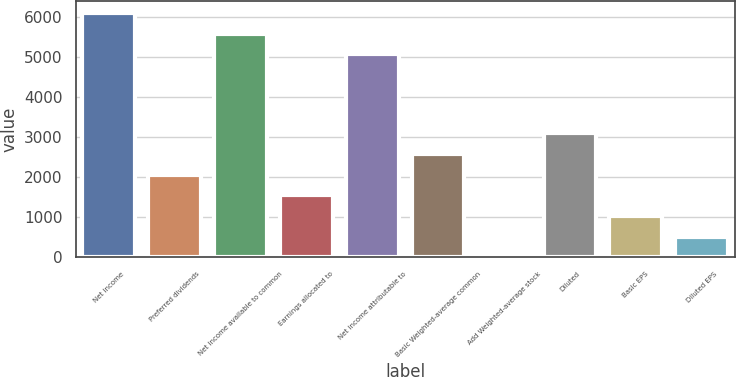Convert chart to OTSL. <chart><loc_0><loc_0><loc_500><loc_500><bar_chart><fcel>Net income<fcel>Preferred dividends<fcel>Net income available to common<fcel>Earnings allocated to<fcel>Net income attributable to<fcel>Basic Weighted-average common<fcel>Add Weighted-average stock<fcel>Diluted<fcel>Basic EPS<fcel>Diluted EPS<nl><fcel>6094.8<fcel>2067.6<fcel>5578.9<fcel>1551.7<fcel>5063<fcel>2583.5<fcel>4<fcel>3099.4<fcel>1035.8<fcel>519.9<nl></chart> 